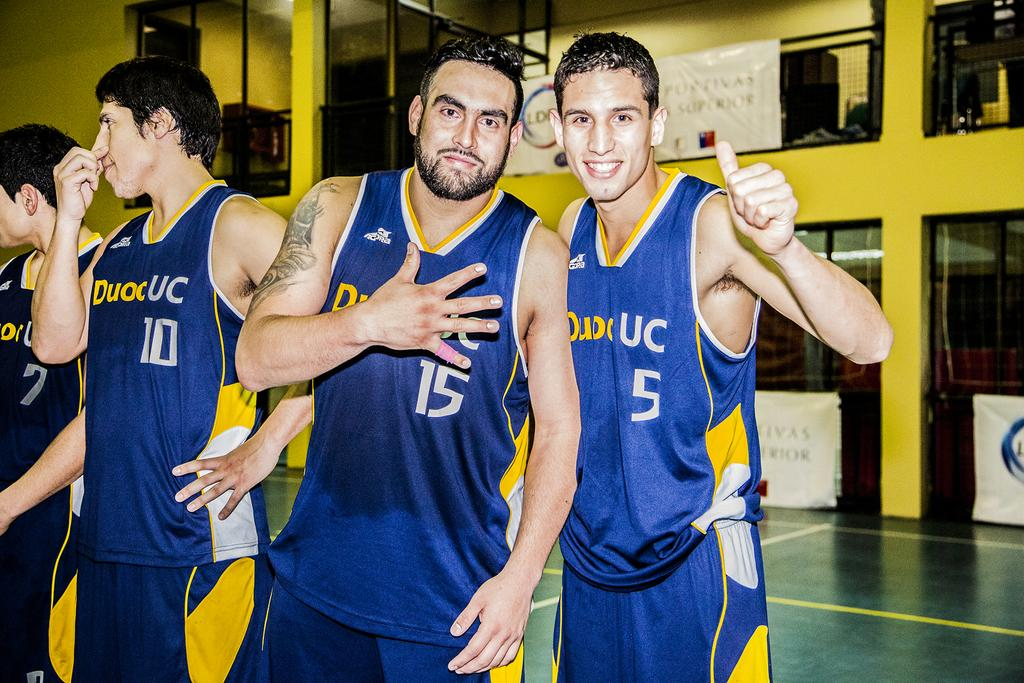<image>
Provide a brief description of the given image. Players 10, 15, 5 are shown in this basketball team photo. 